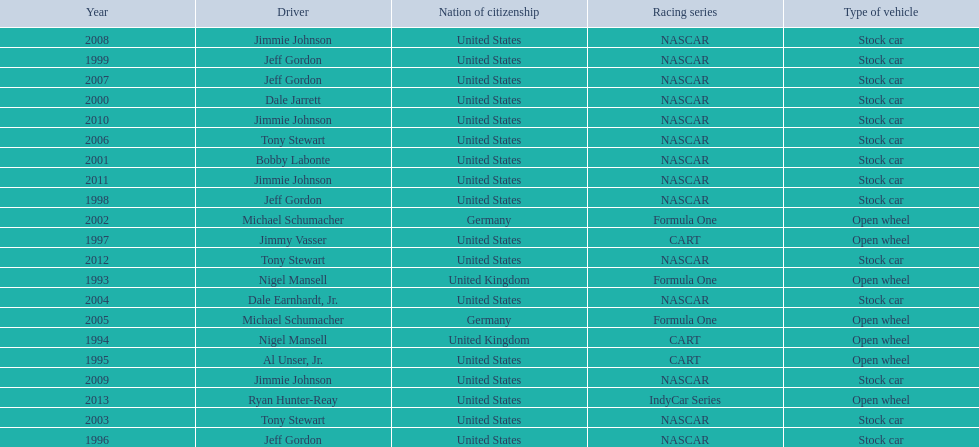Who won an espy in the year 2004, bobby labonte, tony stewart, dale earnhardt jr., or jeff gordon? Dale Earnhardt, Jr. Who won the espy in the year 1997; nigel mansell, al unser, jr., jeff gordon, or jimmy vasser? Jimmy Vasser. Which one only has one espy; nigel mansell, al unser jr., michael schumacher, or jeff gordon? Al Unser, Jr. 